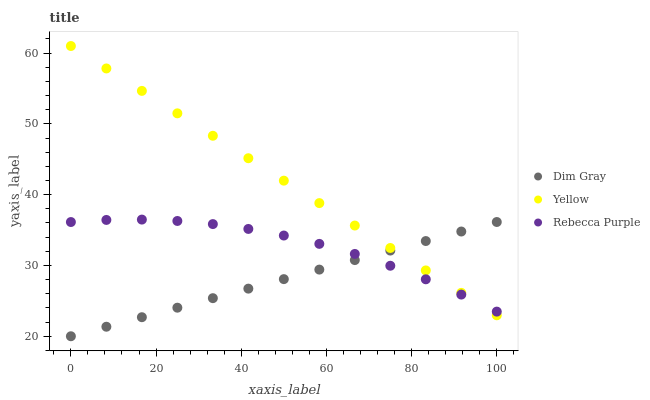Does Dim Gray have the minimum area under the curve?
Answer yes or no. Yes. Does Yellow have the maximum area under the curve?
Answer yes or no. Yes. Does Rebecca Purple have the minimum area under the curve?
Answer yes or no. No. Does Rebecca Purple have the maximum area under the curve?
Answer yes or no. No. Is Dim Gray the smoothest?
Answer yes or no. Yes. Is Rebecca Purple the roughest?
Answer yes or no. Yes. Is Yellow the smoothest?
Answer yes or no. No. Is Yellow the roughest?
Answer yes or no. No. Does Dim Gray have the lowest value?
Answer yes or no. Yes. Does Yellow have the lowest value?
Answer yes or no. No. Does Yellow have the highest value?
Answer yes or no. Yes. Does Rebecca Purple have the highest value?
Answer yes or no. No. Does Dim Gray intersect Rebecca Purple?
Answer yes or no. Yes. Is Dim Gray less than Rebecca Purple?
Answer yes or no. No. Is Dim Gray greater than Rebecca Purple?
Answer yes or no. No. 